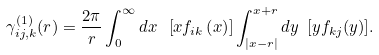Convert formula to latex. <formula><loc_0><loc_0><loc_500><loc_500>\gamma _ { i j , k } ^ { ( 1 ) } ( r ) = \frac { 2 \pi } { r } \int _ { 0 } ^ { \infty } d x \ \left [ x f _ { i k } \left ( x \right ) \right ] \int _ { \left | x - r \right | } ^ { x + r } d y \ [ y f _ { k j } ( y ) ] .</formula> 